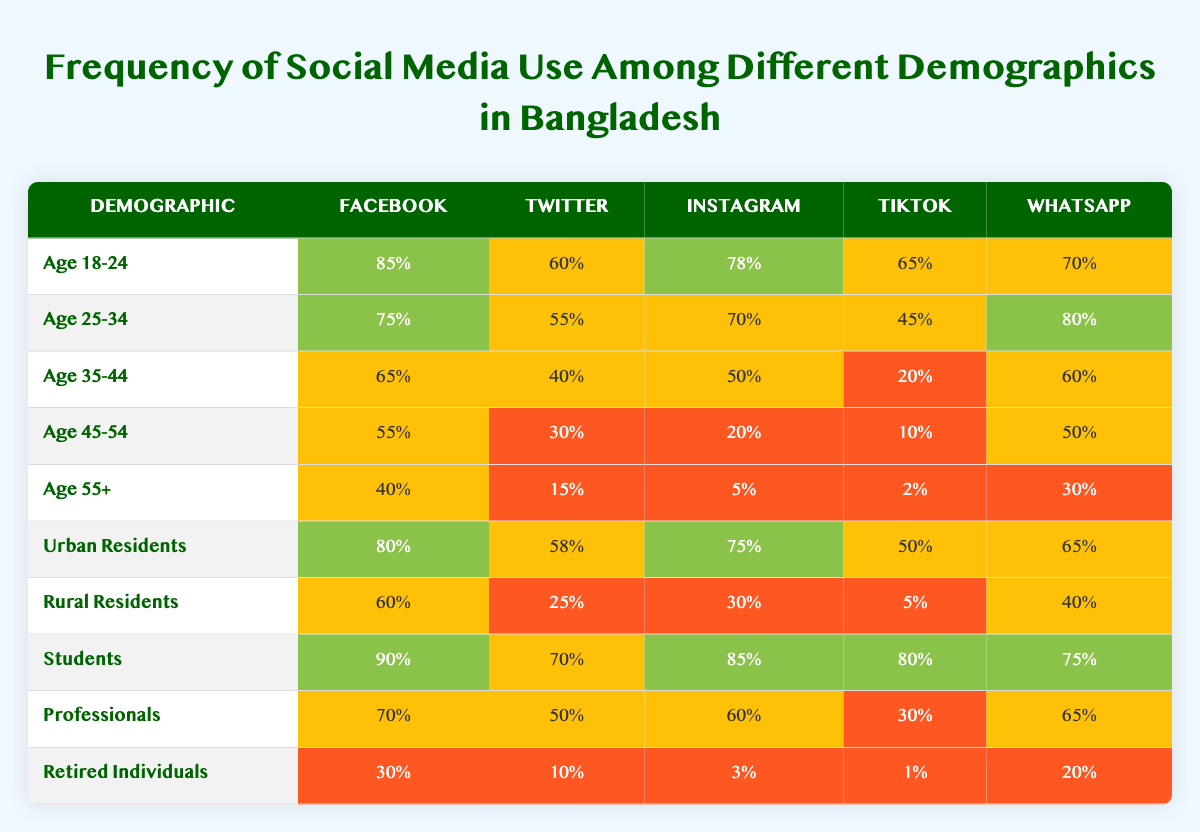What age group has the highest percentage of Facebook use? Looking at the table, the age group 18-24 shows a Facebook usage of 85%, which is higher than other groups.
Answer: Age 18-24 Which demographic has the lowest percentage of TikTok use? From the table, the demographic 'Age 55+' shows only 2% TikTok usage, which is the lowest compared to other demographics.
Answer: Age 55+ What is the average percentage of Instagram use across all age groups? The Instagram percentages for the age groups are: 78%, 70%, 50%, 20%, and 5%. Summing these up gives 78 + 70 + 50 + 20 + 5 = 223. Dividing by 5 (the total number of age groups) results in 223 / 5 = 44.6.
Answer: 44.6% Do students use Twitter more than professionals? According to the table, students use Twitter at 70% while professionals use it at 50%. Therefore, students have a higher usage.
Answer: Yes How does Facebook usage among urban residents compare to the retired individuals? Urban residents use Facebook at 80%, while retired individuals use it at 30%. The difference is 80 - 30 = 50%. This shows urban residents have significantly higher usage compared to retired individuals.
Answer: 50% What is the combined percentage of WhatsApp use for the age groups 35-44 and 45-54? The WhatsApp usage for age groups 35-44 and 45-54 are 60% and 50%, respectively. The combined percentage is 60 + 50 = 110%.
Answer: 110% Which group has the highest usage of Instagram? The demographic of students has the highest Instagram usage at 85%, which is higher than any other group indicated in the table.
Answer: Students Is the percentage of TikTok use among rural residents greater than that of age 45-54? The percentage of TikTok use for rural residents is 5%, and for age group 45-54 it is 10%. Since 5% is less than 10%, the answer is false.
Answer: No What percentage of professionals use Facebook compared to the average percentage of Instagram use across all groups? Professionals use Facebook at 70%, and the average Instagram usage across the groups is 44.6%. Since 70% is greater than 44.6%, the comparison shows that Facebook use is higher.
Answer: Yes How much higher is WhatsApp usage among students compared to retired individuals? Students use WhatsApp at 75%, while retired individuals use it at 20%. The difference is calculated as 75 - 20 = 55%.
Answer: 55% 